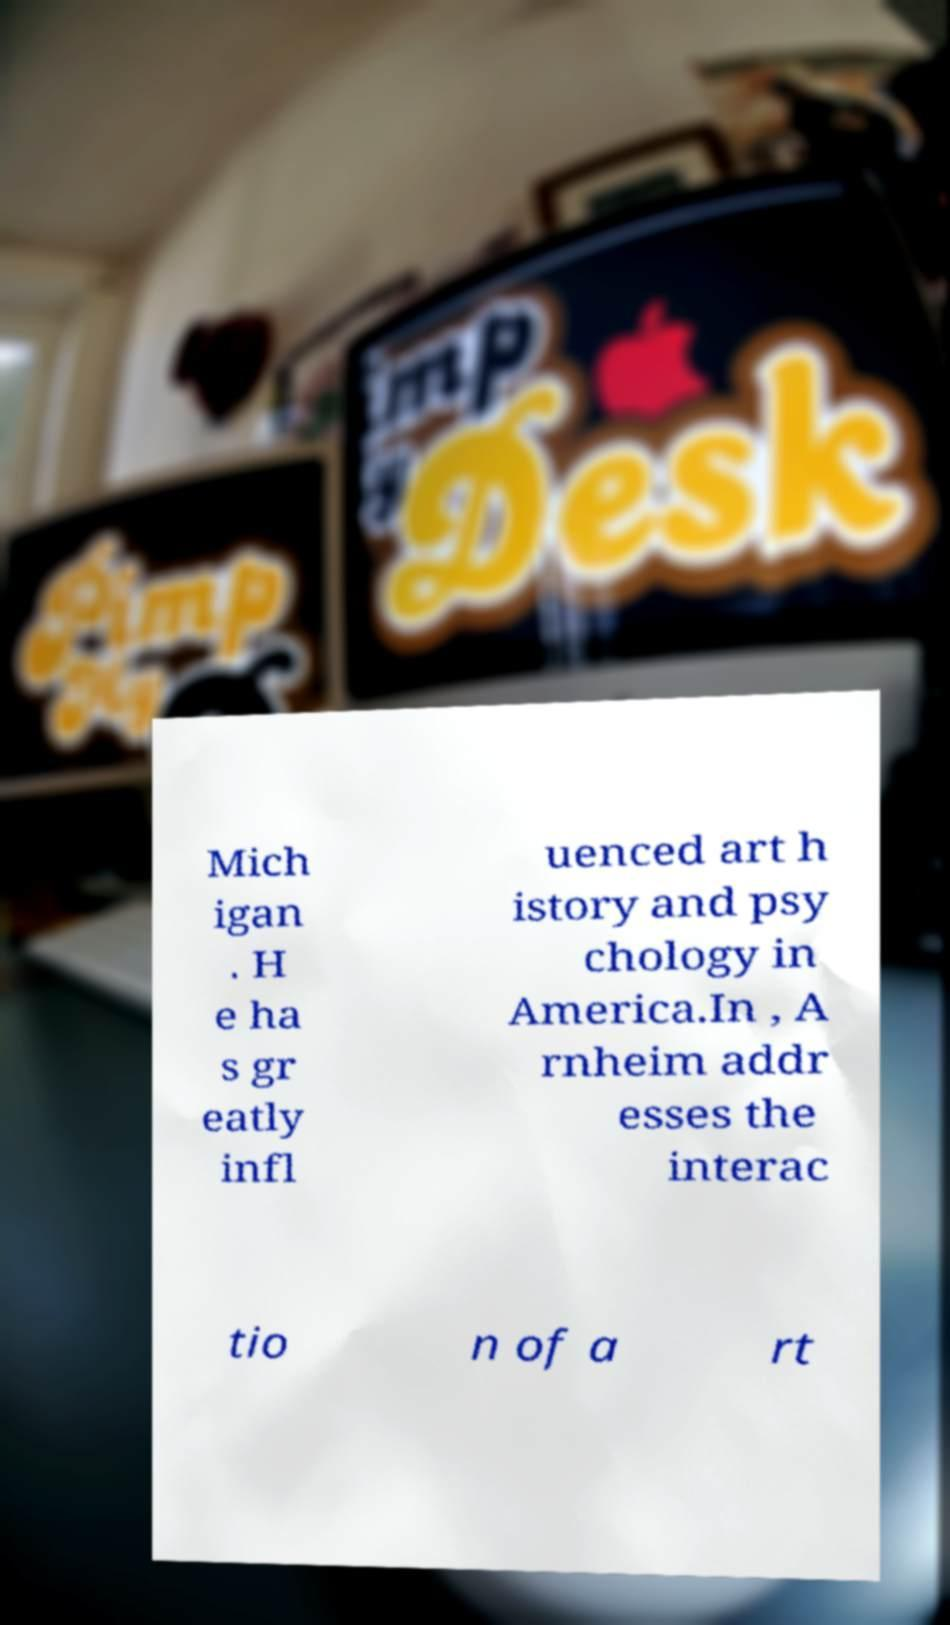I need the written content from this picture converted into text. Can you do that? Mich igan . H e ha s gr eatly infl uenced art h istory and psy chology in America.In , A rnheim addr esses the interac tio n of a rt 